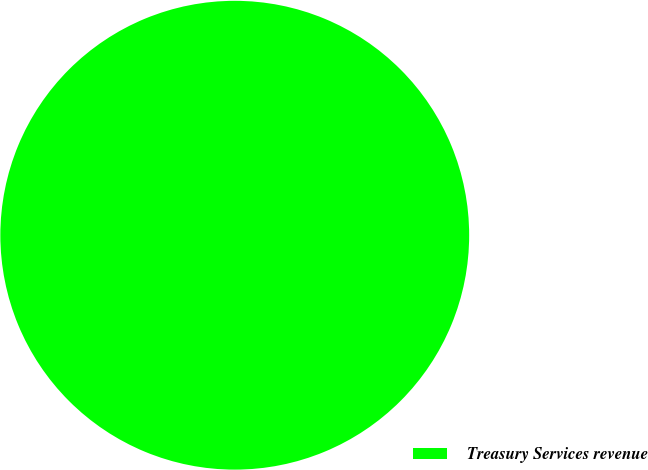Convert chart to OTSL. <chart><loc_0><loc_0><loc_500><loc_500><pie_chart><fcel>Treasury Services revenue<nl><fcel>100.0%<nl></chart> 